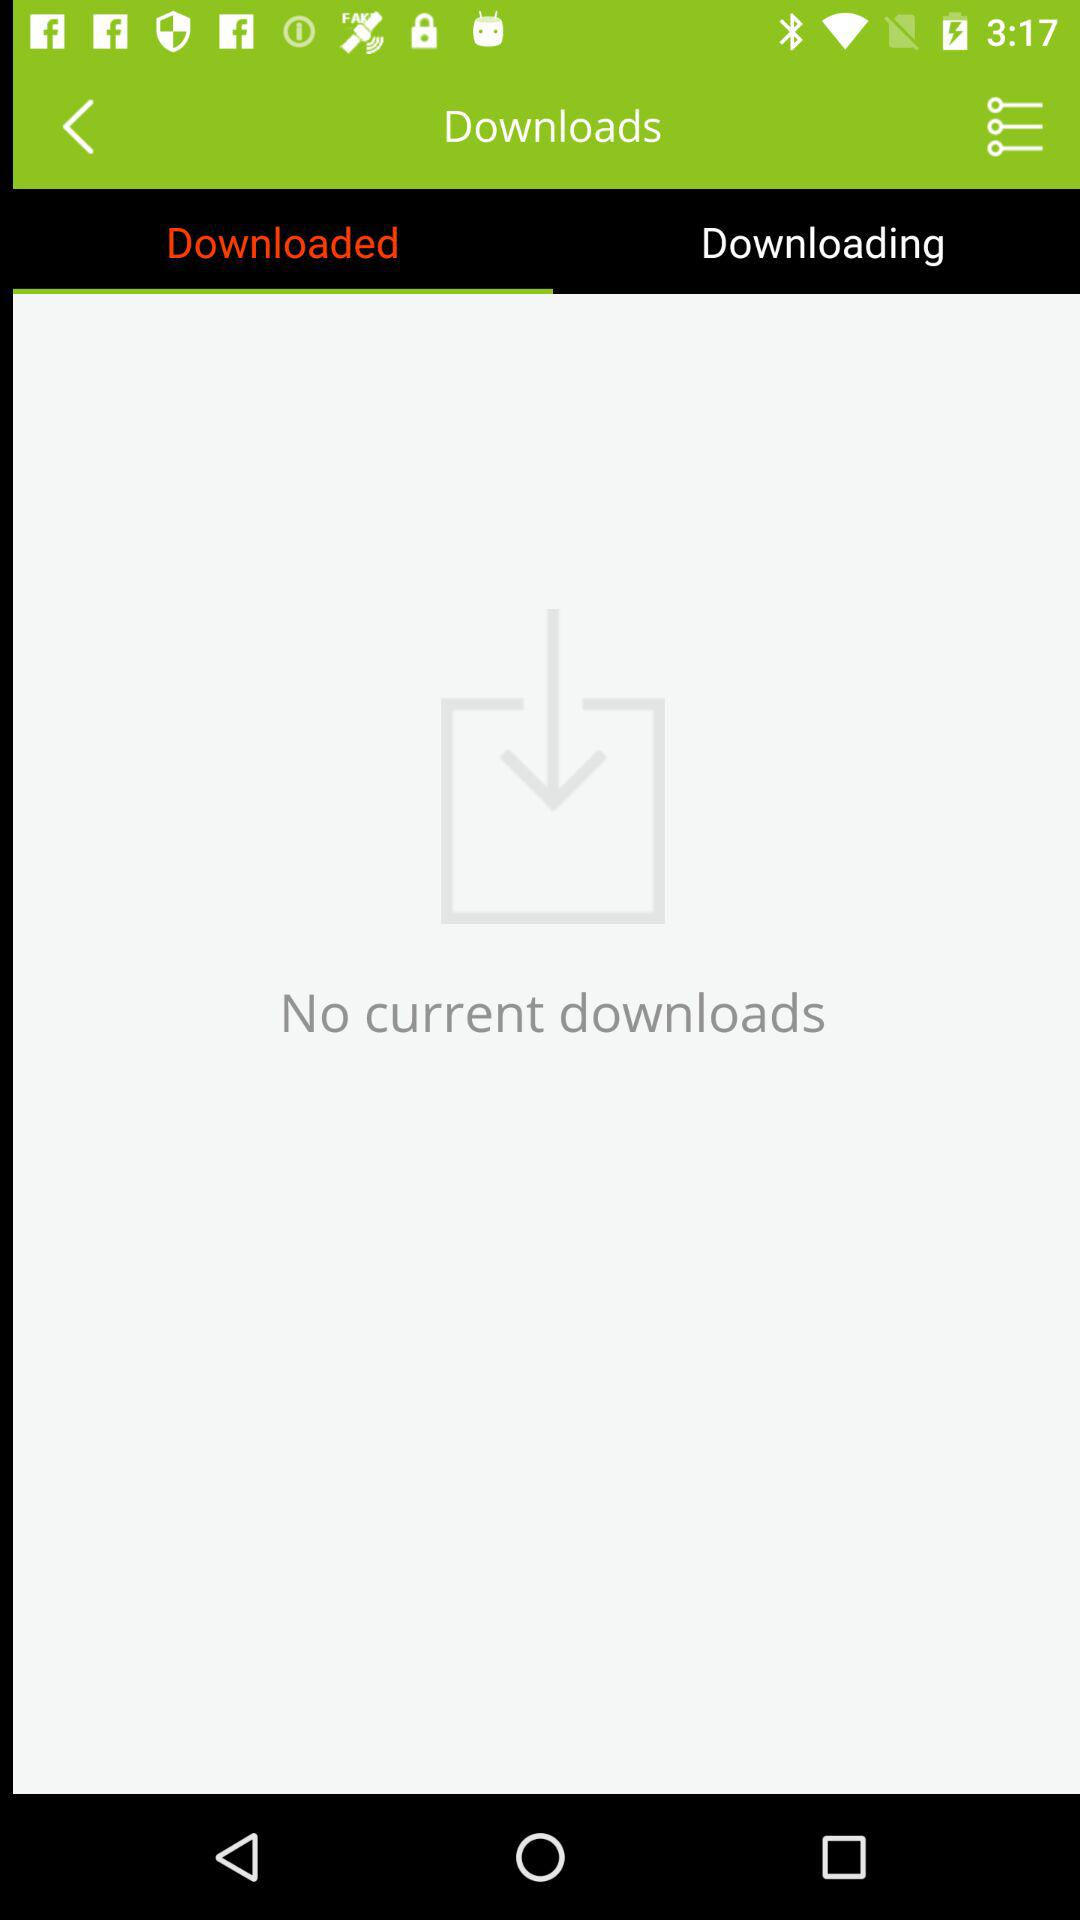Are there any downloads? There are no downloads. 